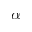<formula> <loc_0><loc_0><loc_500><loc_500>\alpha</formula> 